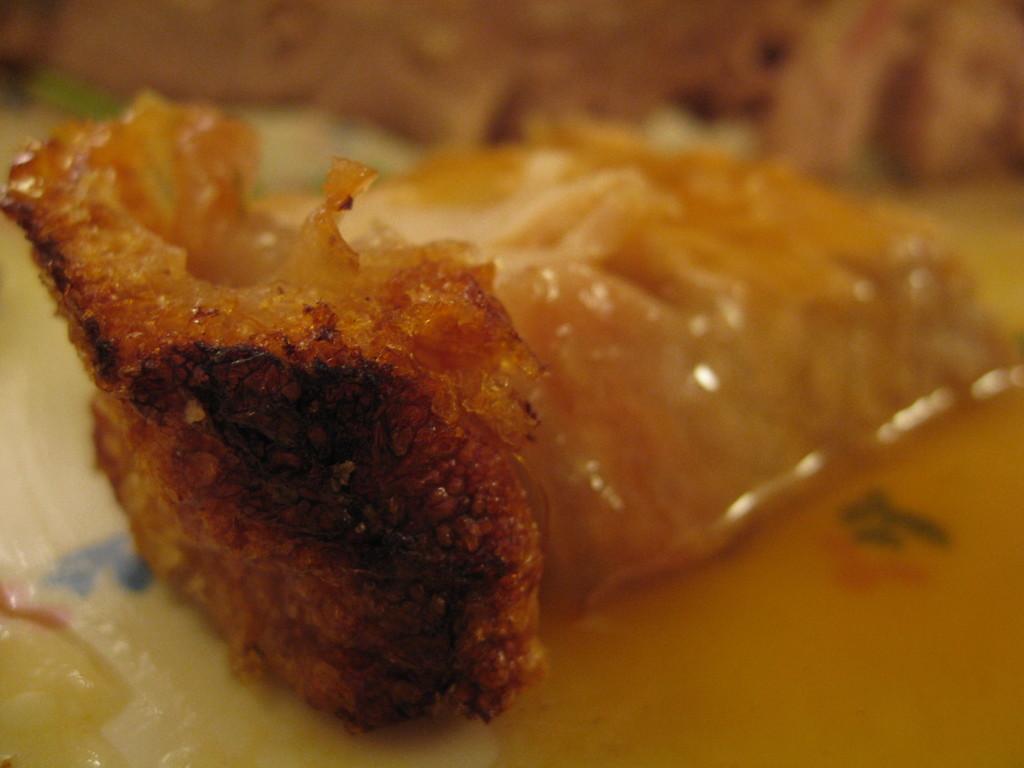Could you give a brief overview of what you see in this image? This is a zoomed in picture. In the center we can see the food item is placed on the top of an object. The background of the image is blur. In the background there is an object seems to be the food item. 